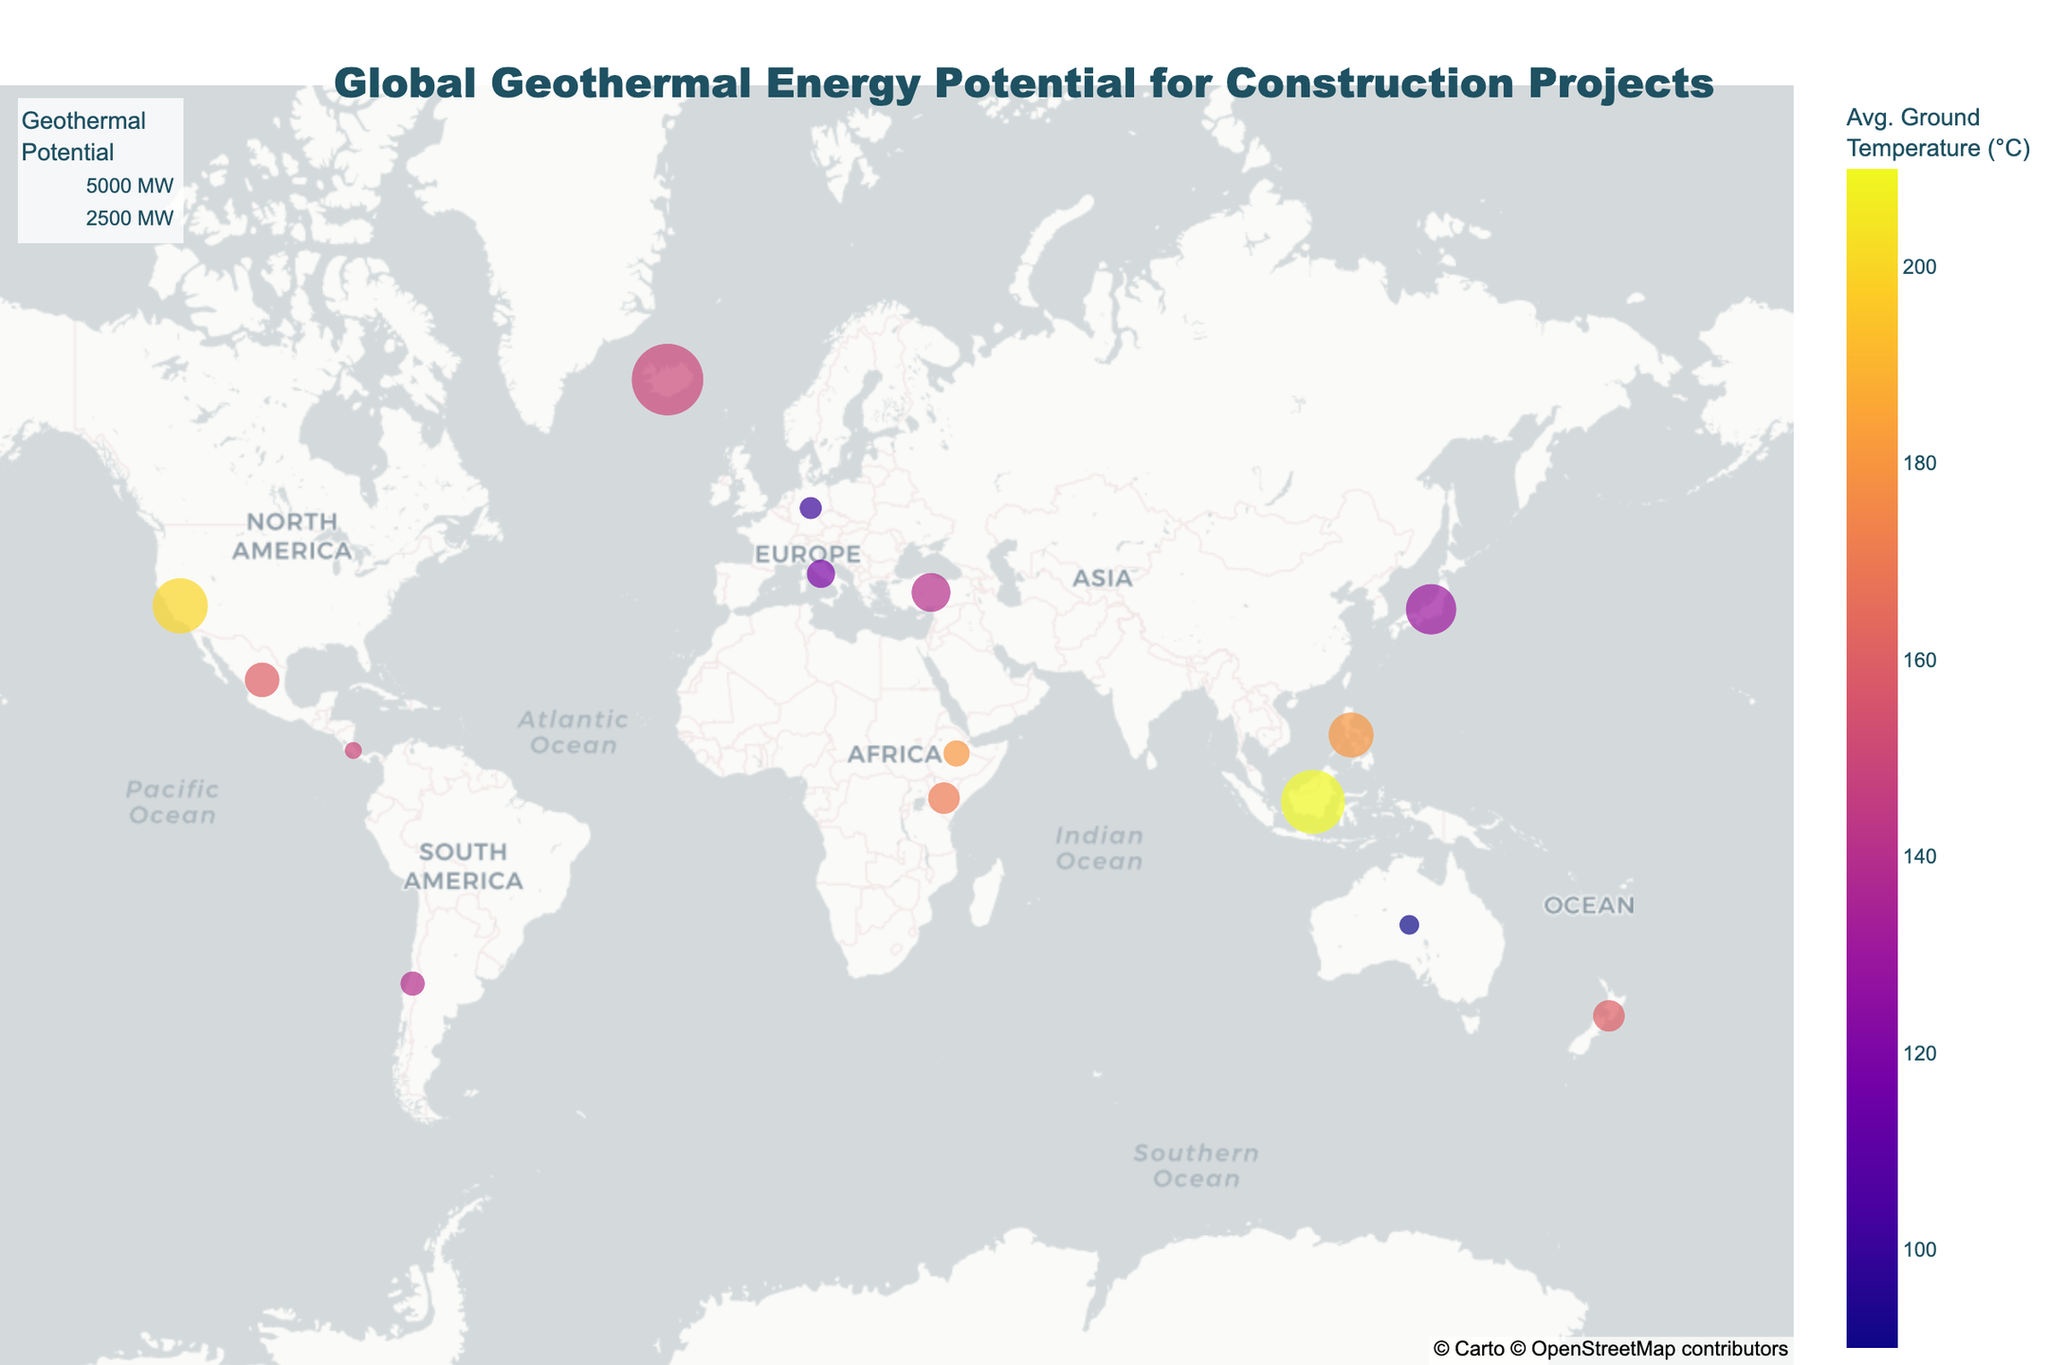Can you identify three regions with high suitability for construction? The map displays regions with high suitability for construction as labeled in the hover data. From the map, we can see that Iceland, New Zealand, and Turkey are marked as high suitability.
Answer: Iceland, New Zealand, Turkey Which region has the highest average ground temperature, and what's the value? The color intensity on the map indicates the average ground temperature, with darker colors representing higher temperatures. From the map, Indonesia is marked with the highest temperature of 210°C.
Answer: Indonesia, 210°C What's the total geothermal potential (MW) of regions with low suitability for construction? Examining the map, Costa Rica and Ethiopia are the regions labeled as low suitability for construction. Summing their geothermal potentials: 400 MW (Australia) + 700 MW (Ethiopia) = 1100 MW.
Answer: 1100 MW How does the geothermal potential of Turkey compare to that of Japan? By comparing the sizes of the bubbles for Turkey and Japan on the map, we can observe that Turkey has a geothermal potential of 1500 MW, whereas Japan has 2500 MW. Hence, Japan's geothermal potential is higher.
Answer: Japan has higher potential Which region has the lowest geothermal potential, and what is its suitability for construction? The map identifies Australia with the smallest circle size, indicating the lowest geothermal potential of 400 MW. Its suitability for construction is marked as low.
Answer: Australia, low What's the sum of geothermal potential in the regions with medium suitability for construction? Summing up the geothermal potentials for regions with medium suitability: California USA (3000 MW) + Philippines (2000 MW) + Indonesia (4000 MW) + Kenya (1000 MW) + Japan (2500 MW) + Mexico (1200 MW) + Chile (600 MW) = 14300 MW.
Answer: 14300 MW Which regions have an average ground temperature between 120°C and 160°C, and what are their geothermal potentials? Observing the color scale and hover data, Turkey (140°C, 1500 MW), Italy (120°C, 800 MW), New Zealand (160°C, 1000 MW), Mexico (160°C, 1200 MW), and Germany (100°C, 500 MW) fit the temperature range.
Answer: Turkey (1500 MW), Italy (800 MW), New Zealand (1000 MW), Mexico (1200 MW), Germany (500 MW) Which region with high construction suitability has the highest geothermal potential? From the regions marked as high suitability on the map, Iceland exhibits the largest circle corresponding to the highest geothermal potential of 5000 MW.
Answer: Iceland What’s the average geothermal potential of regions with high suitability for construction? Summing the geothermal potentials and dividing by the number of regions: (Iceland 5000 MW + New Zealand 1000 MW + Turkey 1500 MW + Italy 800 MW + Germany 500 MW + Costa Rica 300 MW) / 6 regions = 9100 / 6 = 1516.67 MW.
Answer: 1516.67 MW 